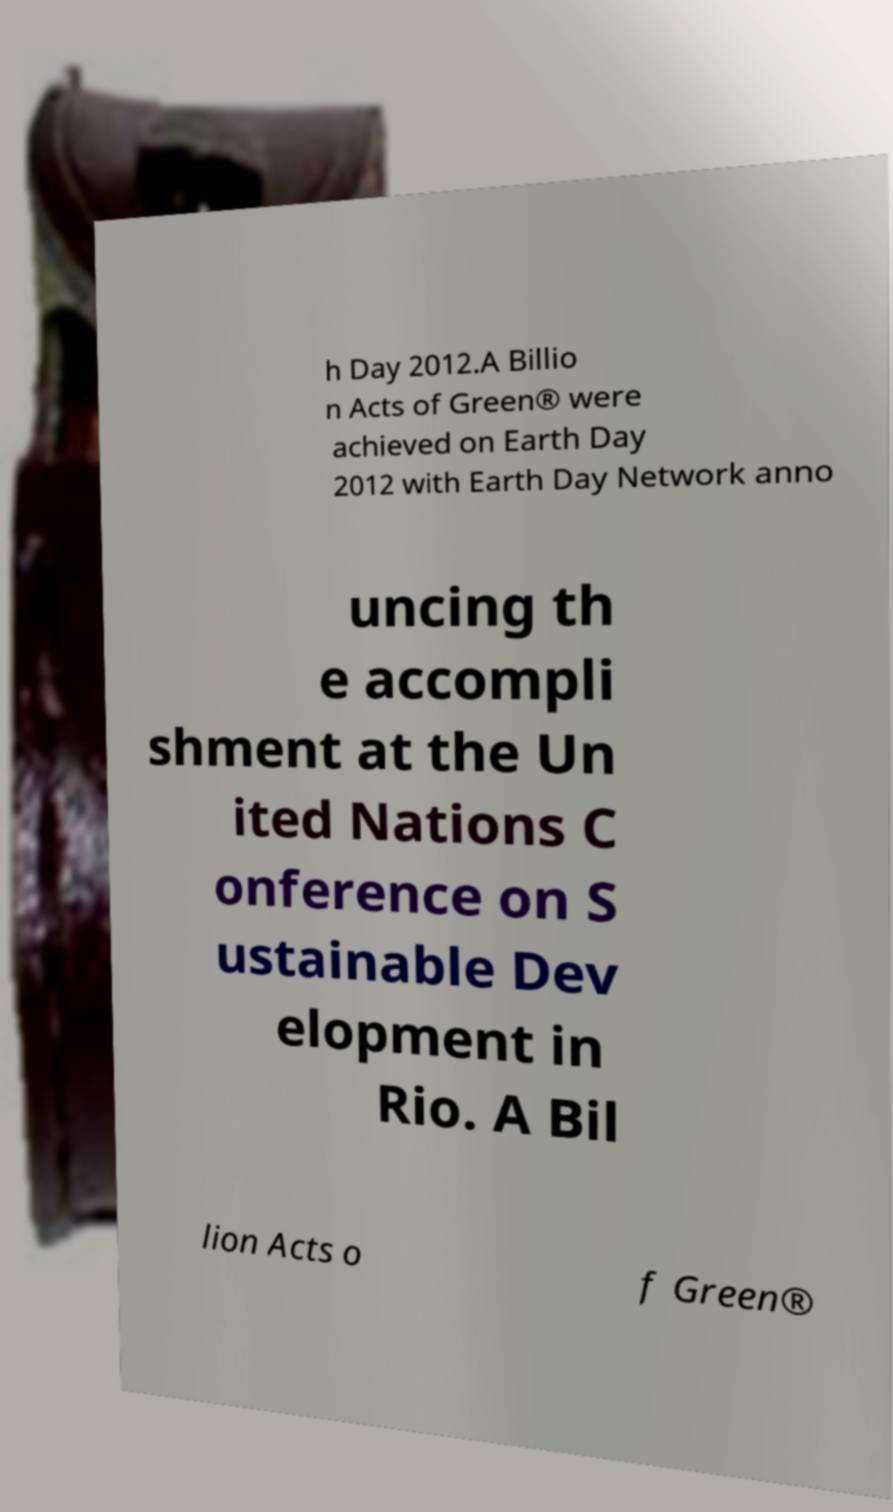Can you accurately transcribe the text from the provided image for me? h Day 2012.A Billio n Acts of Green® were achieved on Earth Day 2012 with Earth Day Network anno uncing th e accompli shment at the Un ited Nations C onference on S ustainable Dev elopment in Rio. A Bil lion Acts o f Green® 